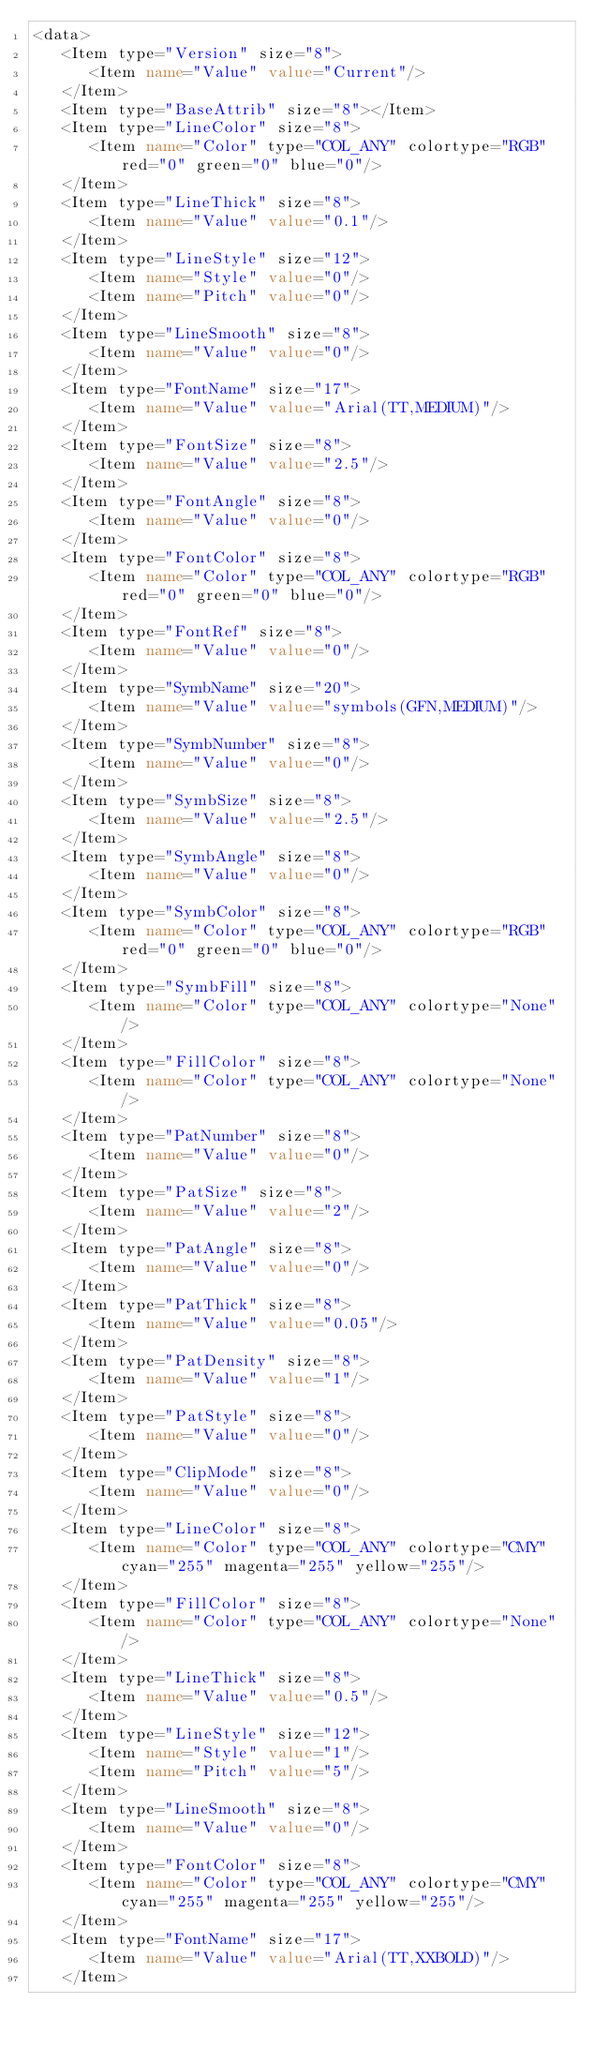Convert code to text. <code><loc_0><loc_0><loc_500><loc_500><_XML_><data>
   <Item type="Version" size="8">
      <Item name="Value" value="Current"/>
   </Item>
   <Item type="BaseAttrib" size="8"></Item>
   <Item type="LineColor" size="8">
      <Item name="Color" type="COL_ANY" colortype="RGB" red="0" green="0" blue="0"/>
   </Item>
   <Item type="LineThick" size="8">
      <Item name="Value" value="0.1"/>
   </Item>
   <Item type="LineStyle" size="12">
      <Item name="Style" value="0"/>
      <Item name="Pitch" value="0"/>
   </Item>
   <Item type="LineSmooth" size="8">
      <Item name="Value" value="0"/>
   </Item>
   <Item type="FontName" size="17">
      <Item name="Value" value="Arial(TT,MEDIUM)"/>
   </Item>
   <Item type="FontSize" size="8">
      <Item name="Value" value="2.5"/>
   </Item>
   <Item type="FontAngle" size="8">
      <Item name="Value" value="0"/>
   </Item>
   <Item type="FontColor" size="8">
      <Item name="Color" type="COL_ANY" colortype="RGB" red="0" green="0" blue="0"/>
   </Item>
   <Item type="FontRef" size="8">
      <Item name="Value" value="0"/>
   </Item>
   <Item type="SymbName" size="20">
      <Item name="Value" value="symbols(GFN,MEDIUM)"/>
   </Item>
   <Item type="SymbNumber" size="8">
      <Item name="Value" value="0"/>
   </Item>
   <Item type="SymbSize" size="8">
      <Item name="Value" value="2.5"/>
   </Item>
   <Item type="SymbAngle" size="8">
      <Item name="Value" value="0"/>
   </Item>
   <Item type="SymbColor" size="8">
      <Item name="Color" type="COL_ANY" colortype="RGB" red="0" green="0" blue="0"/>
   </Item>
   <Item type="SymbFill" size="8">
      <Item name="Color" type="COL_ANY" colortype="None"/>
   </Item>
   <Item type="FillColor" size="8">
      <Item name="Color" type="COL_ANY" colortype="None"/>
   </Item>
   <Item type="PatNumber" size="8">
      <Item name="Value" value="0"/>
   </Item>
   <Item type="PatSize" size="8">
      <Item name="Value" value="2"/>
   </Item>
   <Item type="PatAngle" size="8">
      <Item name="Value" value="0"/>
   </Item>
   <Item type="PatThick" size="8">
      <Item name="Value" value="0.05"/>
   </Item>
   <Item type="PatDensity" size="8">
      <Item name="Value" value="1"/>
   </Item>
   <Item type="PatStyle" size="8">
      <Item name="Value" value="0"/>
   </Item>
   <Item type="ClipMode" size="8">
      <Item name="Value" value="0"/>
   </Item>
   <Item type="LineColor" size="8">
      <Item name="Color" type="COL_ANY" colortype="CMY" cyan="255" magenta="255" yellow="255"/>
   </Item>
   <Item type="FillColor" size="8">
      <Item name="Color" type="COL_ANY" colortype="None"/>
   </Item>
   <Item type="LineThick" size="8">
      <Item name="Value" value="0.5"/>
   </Item>
   <Item type="LineStyle" size="12">
      <Item name="Style" value="1"/>
      <Item name="Pitch" value="5"/>
   </Item>
   <Item type="LineSmooth" size="8">
      <Item name="Value" value="0"/>
   </Item>
   <Item type="FontColor" size="8">
      <Item name="Color" type="COL_ANY" colortype="CMY" cyan="255" magenta="255" yellow="255"/>
   </Item>
   <Item type="FontName" size="17">
      <Item name="Value" value="Arial(TT,XXBOLD)"/>
   </Item></code> 